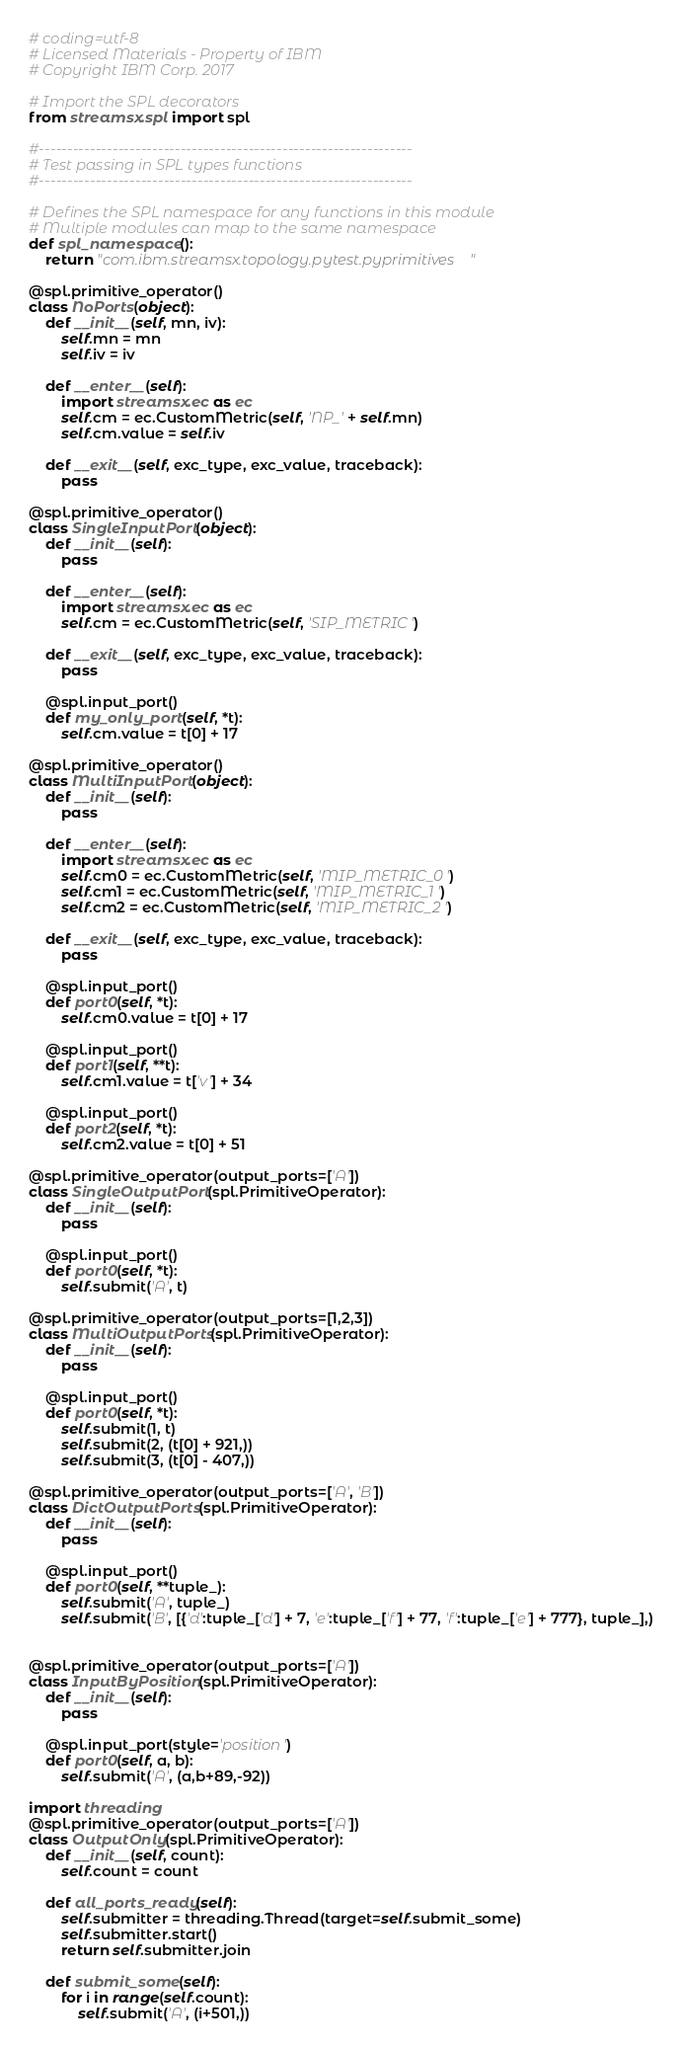<code> <loc_0><loc_0><loc_500><loc_500><_Python_># coding=utf-8
# Licensed Materials - Property of IBM
# Copyright IBM Corp. 2017

# Import the SPL decorators
from streamsx.spl import spl

#------------------------------------------------------------------
# Test passing in SPL types functions
#------------------------------------------------------------------

# Defines the SPL namespace for any functions in this module
# Multiple modules can map to the same namespace
def spl_namespace():
    return "com.ibm.streamsx.topology.pytest.pyprimitives"

@spl.primitive_operator()
class NoPorts(object):
    def __init__(self, mn, iv):
        self.mn = mn
        self.iv = iv

    def __enter__(self):
        import streamsx.ec as ec
        self.cm = ec.CustomMetric(self, 'NP_' + self.mn)
        self.cm.value = self.iv

    def __exit__(self, exc_type, exc_value, traceback):
        pass
   
@spl.primitive_operator()
class SingleInputPort(object):
    def __init__(self):
        pass

    def __enter__(self):
        import streamsx.ec as ec
        self.cm = ec.CustomMetric(self, 'SIP_METRIC')

    def __exit__(self, exc_type, exc_value, traceback):
        pass

    @spl.input_port()
    def my_only_port(self, *t):
        self.cm.value = t[0] + 17

@spl.primitive_operator()
class MultiInputPort(object):
    def __init__(self):
        pass

    def __enter__(self):
        import streamsx.ec as ec
        self.cm0 = ec.CustomMetric(self, 'MIP_METRIC_0')
        self.cm1 = ec.CustomMetric(self, 'MIP_METRIC_1')
        self.cm2 = ec.CustomMetric(self, 'MIP_METRIC_2')

    def __exit__(self, exc_type, exc_value, traceback):
        pass

    @spl.input_port()
    def port0(self, *t):
        self.cm0.value = t[0] + 17

    @spl.input_port()
    def port1(self, **t):
        self.cm1.value = t['v'] + 34

    @spl.input_port()
    def port2(self, *t):
        self.cm2.value = t[0] + 51

@spl.primitive_operator(output_ports=['A'])
class SingleOutputPort(spl.PrimitiveOperator):
    def __init__(self):
        pass

    @spl.input_port()
    def port0(self, *t):
        self.submit('A', t)

@spl.primitive_operator(output_ports=[1,2,3])
class MultiOutputPorts(spl.PrimitiveOperator):
    def __init__(self):
        pass

    @spl.input_port()
    def port0(self, *t):
        self.submit(1, t)
        self.submit(2, (t[0] + 921,))
        self.submit(3, (t[0] - 407,))

@spl.primitive_operator(output_ports=['A', 'B'])
class DictOutputPorts(spl.PrimitiveOperator):
    def __init__(self):
        pass

    @spl.input_port()
    def port0(self, **tuple_):
        self.submit('A', tuple_)
        self.submit('B', [{'d':tuple_['d'] + 7, 'e':tuple_['f'] + 77, 'f':tuple_['e'] + 777}, tuple_],)


@spl.primitive_operator(output_ports=['A'])
class InputByPosition(spl.PrimitiveOperator):
    def __init__(self):
        pass

    @spl.input_port(style='position')
    def port0(self, a, b):
        self.submit('A', (a,b+89,-92))

import threading
@spl.primitive_operator(output_ports=['A'])
class OutputOnly(spl.PrimitiveOperator):
    def __init__(self, count):
        self.count = count

    def all_ports_ready(self):
        self.submitter = threading.Thread(target=self.submit_some)
        self.submitter.start()
        return self.submitter.join

    def submit_some(self):
        for i in range(self.count):
            self.submit('A', (i+501,))
</code> 